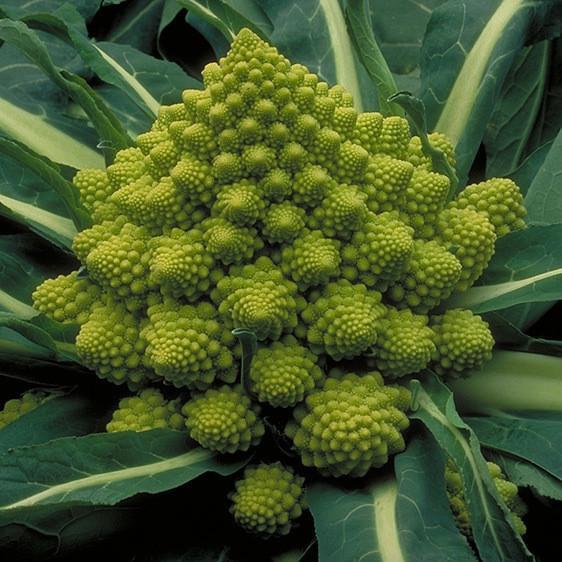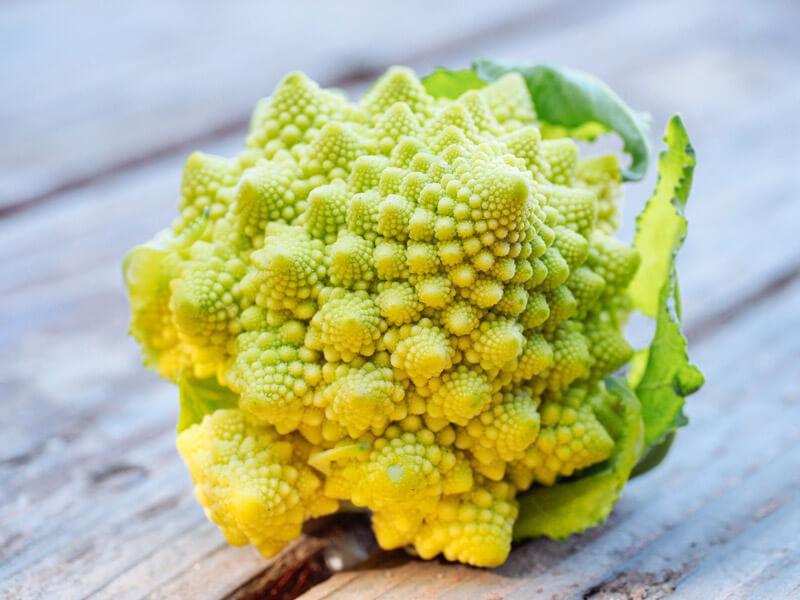The first image is the image on the left, the second image is the image on the right. Assess this claim about the two images: "The image on the left contains cooked food.". Correct or not? Answer yes or no. No. 